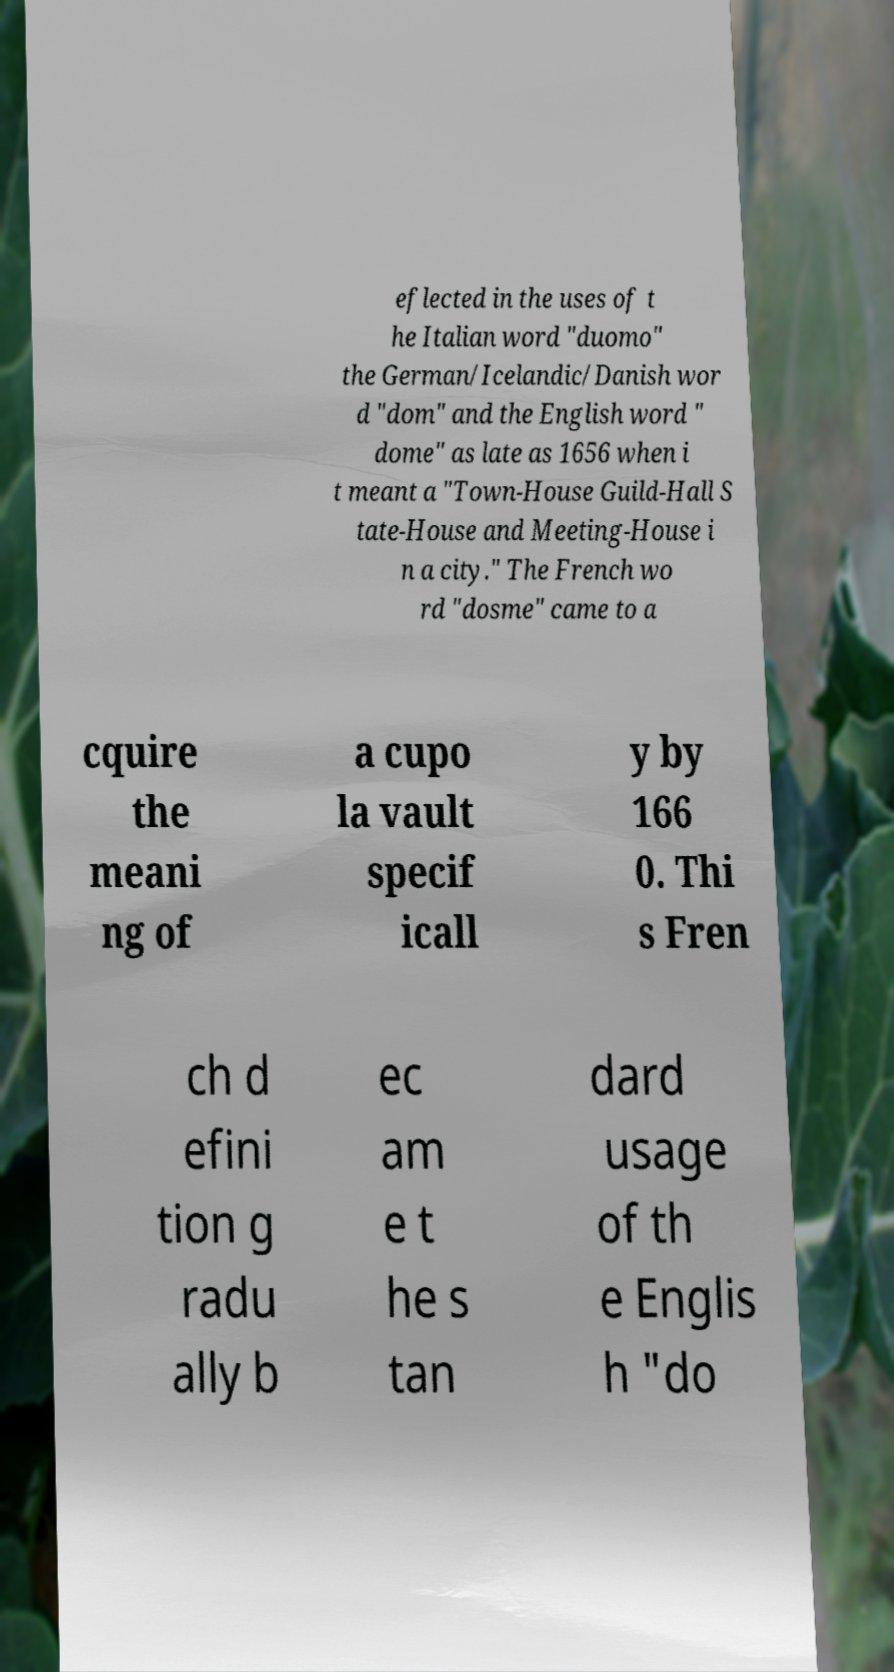Please identify and transcribe the text found in this image. eflected in the uses of t he Italian word "duomo" the German/Icelandic/Danish wor d "dom" and the English word " dome" as late as 1656 when i t meant a "Town-House Guild-Hall S tate-House and Meeting-House i n a city." The French wo rd "dosme" came to a cquire the meani ng of a cupo la vault specif icall y by 166 0. Thi s Fren ch d efini tion g radu ally b ec am e t he s tan dard usage of th e Englis h "do 